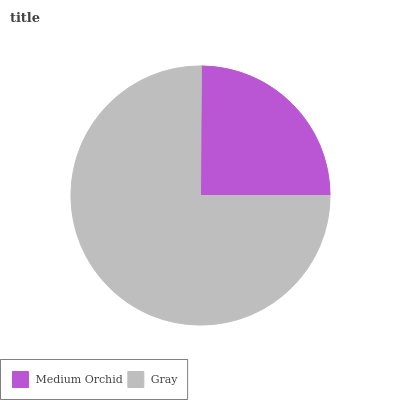Is Medium Orchid the minimum?
Answer yes or no. Yes. Is Gray the maximum?
Answer yes or no. Yes. Is Gray the minimum?
Answer yes or no. No. Is Gray greater than Medium Orchid?
Answer yes or no. Yes. Is Medium Orchid less than Gray?
Answer yes or no. Yes. Is Medium Orchid greater than Gray?
Answer yes or no. No. Is Gray less than Medium Orchid?
Answer yes or no. No. Is Gray the high median?
Answer yes or no. Yes. Is Medium Orchid the low median?
Answer yes or no. Yes. Is Medium Orchid the high median?
Answer yes or no. No. Is Gray the low median?
Answer yes or no. No. 